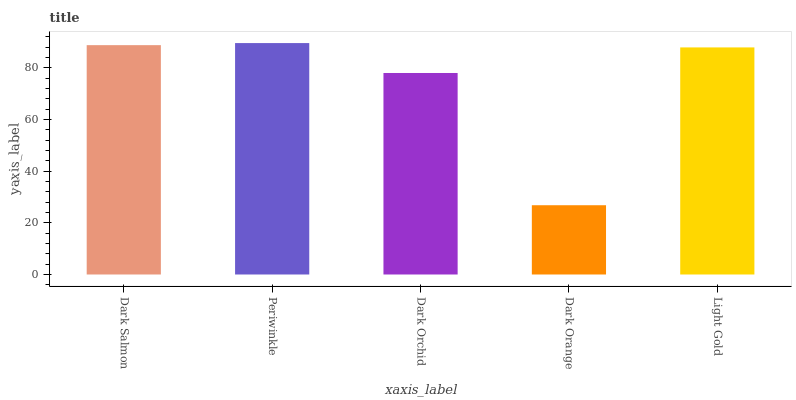Is Dark Orange the minimum?
Answer yes or no. Yes. Is Periwinkle the maximum?
Answer yes or no. Yes. Is Dark Orchid the minimum?
Answer yes or no. No. Is Dark Orchid the maximum?
Answer yes or no. No. Is Periwinkle greater than Dark Orchid?
Answer yes or no. Yes. Is Dark Orchid less than Periwinkle?
Answer yes or no. Yes. Is Dark Orchid greater than Periwinkle?
Answer yes or no. No. Is Periwinkle less than Dark Orchid?
Answer yes or no. No. Is Light Gold the high median?
Answer yes or no. Yes. Is Light Gold the low median?
Answer yes or no. Yes. Is Dark Orange the high median?
Answer yes or no. No. Is Dark Orchid the low median?
Answer yes or no. No. 